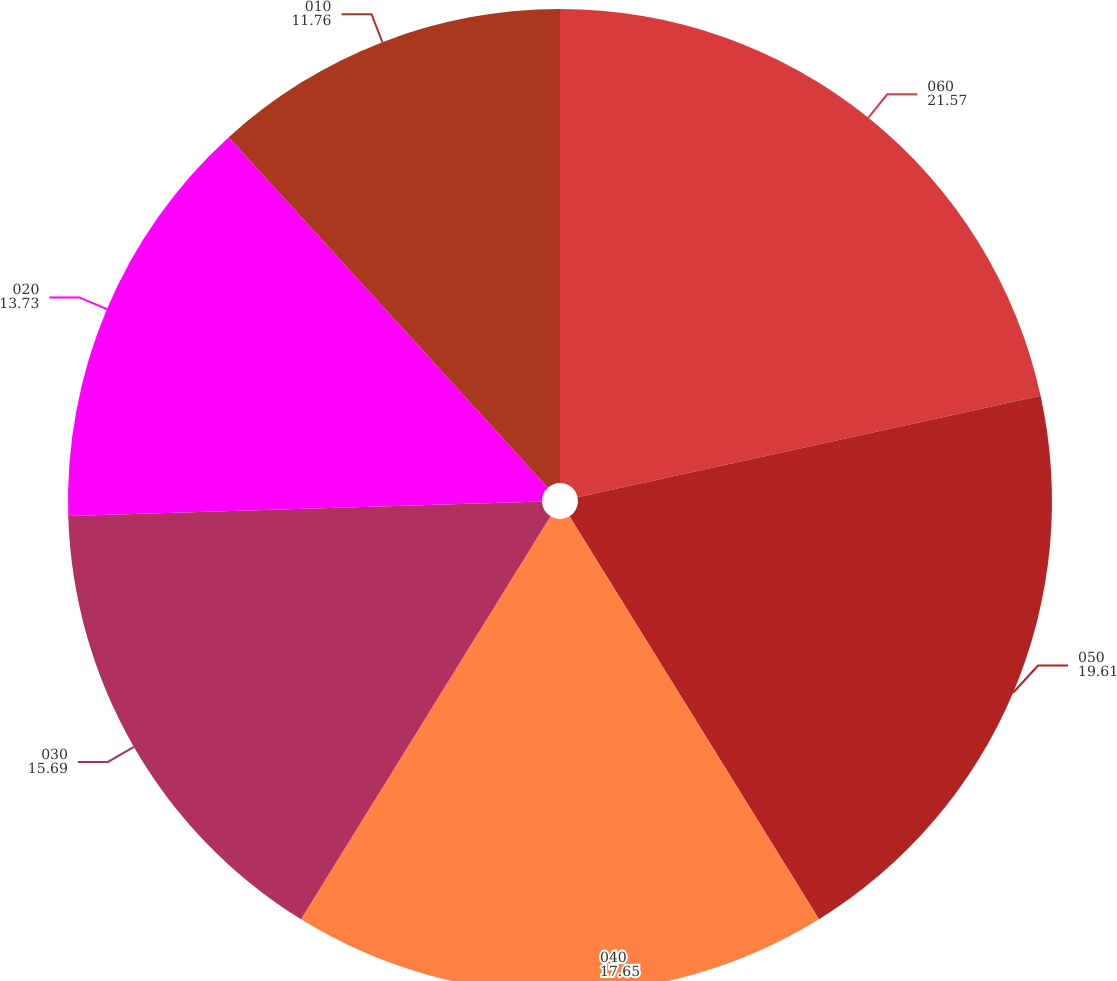<chart> <loc_0><loc_0><loc_500><loc_500><pie_chart><fcel>060<fcel>050<fcel>040<fcel>030<fcel>020<fcel>010<nl><fcel>21.57%<fcel>19.61%<fcel>17.65%<fcel>15.69%<fcel>13.73%<fcel>11.76%<nl></chart> 